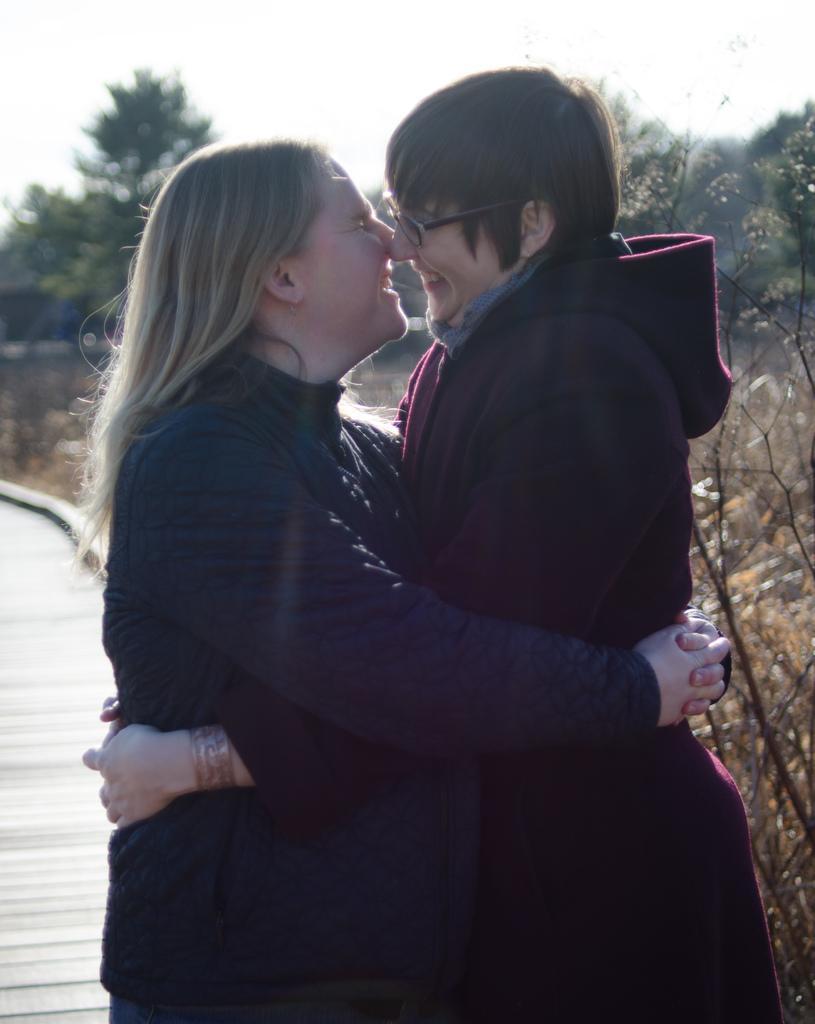How would you summarize this image in a sentence or two? In this image there are two people hugging each other. In the background there are trees and the sky. 